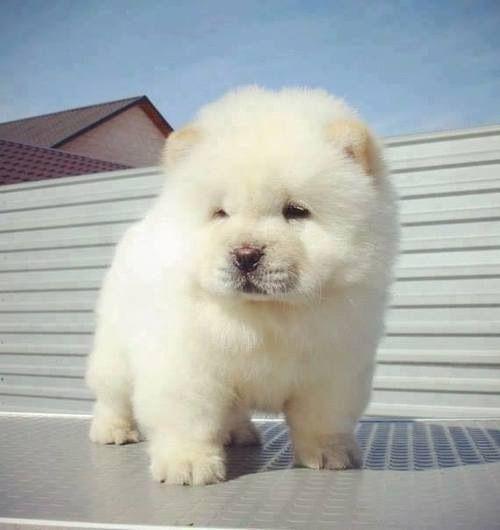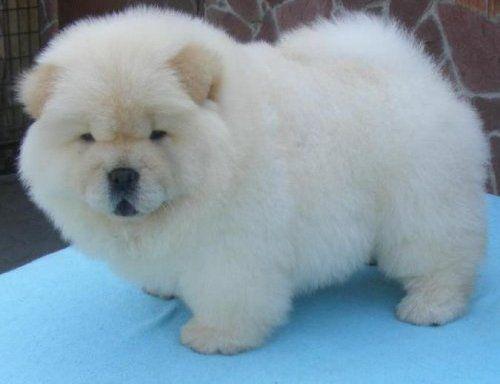The first image is the image on the left, the second image is the image on the right. For the images shown, is this caption "At least two dogs have their mouths open." true? Answer yes or no. No. The first image is the image on the left, the second image is the image on the right. Analyze the images presented: Is the assertion "The left image features a left-turned pale-colored chow standing in front of a person." valid? Answer yes or no. No. 